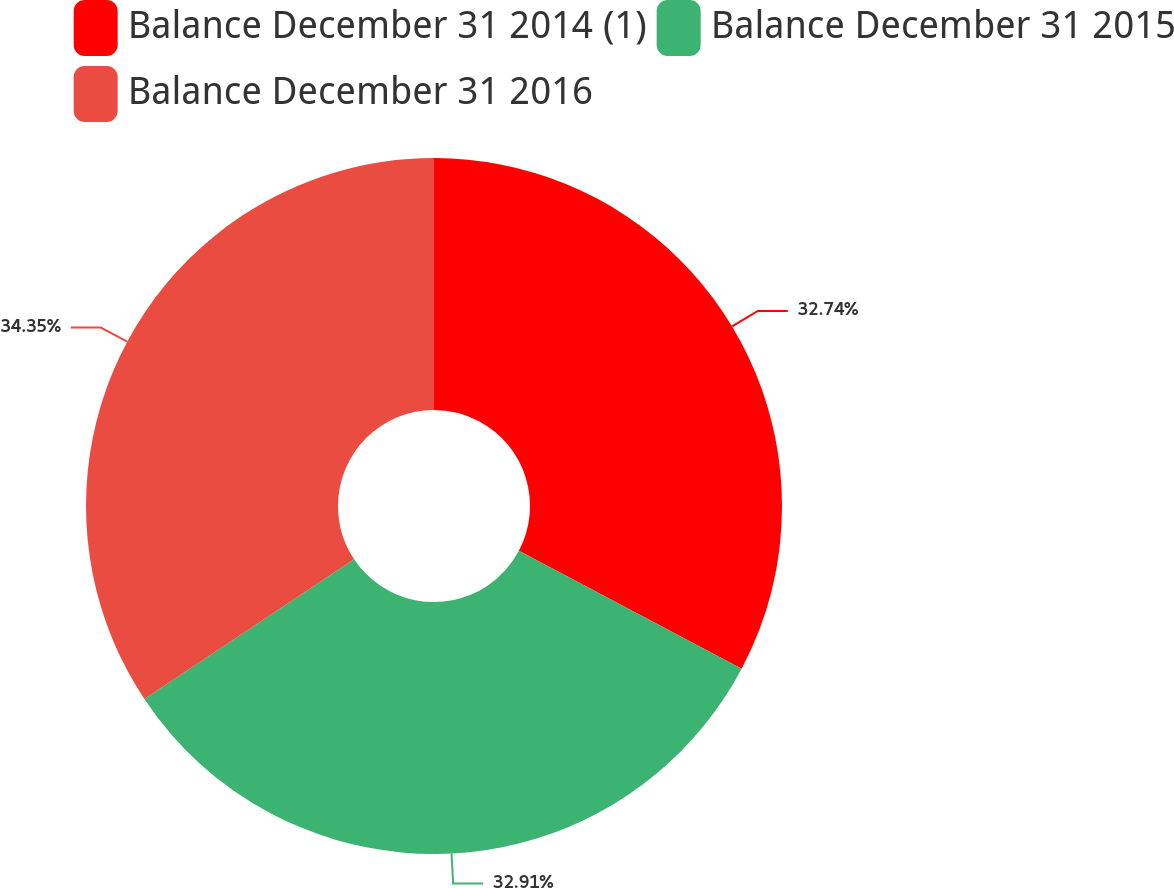Convert chart. <chart><loc_0><loc_0><loc_500><loc_500><pie_chart><fcel>Balance December 31 2014 (1)<fcel>Balance December 31 2015<fcel>Balance December 31 2016<nl><fcel>32.74%<fcel>32.91%<fcel>34.35%<nl></chart> 